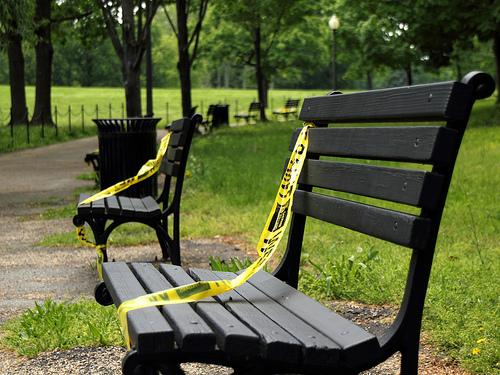How many benches are mentioned in the image? Are there any distinguishing features about these benches? There are a couple of benches with yellow caution tape indicating wet paint, and they seem to be made of wood and are built into the pavement. Identify any possible safety hazards that might be present in this park scene. Potential safety hazards include wet paint on the benches signaled by yellow caution tape. Describe the trash can and its position in the image relative to the benches. A black garbage can is situated in the background, slightly behind and to the side of the benches with caution tape. Based on the information given, provide a simple description of the image. The image shows multiple tall trees, benches with yellow tape, a trash can, and a black fence in a park setting. What standout color is mentioned in the image? What objects have this color? Yellow is the standout color, which is found on caution tape, plastic banner, and dandelions in the scene. Narrate the scene with trees, benches, and caution tape. In a park with tall trees, a couple of wooden benches built into the pavement are wrapped with yellow caution tape, warning of wet paint. Mention any flower species present in the image and their location. Yellow dandelions can be spotted on the ground within the park. Provide a general sentiment analysis of the image. The image has a neutral sentiment, as it depicts an everyday outdoor scene within a park setting. Estimate the total number of objects in the image, including trees, benches, and other items. The image contains at least 31 objects, including trees, benches, and various other items like a trash can, fence, and lightpost. Identify the type of tape on the benches and describe the reason for its presence. Yellow caution tape is placed on the benches, suggesting they are recently painted and still wet. Take a close look at the beautiful red and white flowers growing next to the walking path. Their vibrant colors are striking. There are no red and white flowers mentioned in the image information. This instruction is misleading because it introduces colorful details that are not present in the image. What type of park feature has caution tape wrapped around it? Benches What color are the tape on the benches? Yellow On the bench with the yellow caution tape, you will see a forgotten book. It looks like an interesting read. There is no mention of a forgotten book on any bench in the image information. This instruction is misleading because it introduces a personal item and makes a subjective judgment about its content. What color is the fence in the image? Black Describe the warning message on the tape found on benches. Caution wet paint In addition to the paved path, what other feature is next to the fence? A walking path Provide a brief description of the walking path. A walking path next to the fence and benches Did you notice the flock of birds flying above the park? They appear to be heading south for the winter. There is no reference to a flock of birds or their direction in the image information. This instruction is misleading because it introduces movement and seasonal context that is not present in the image. How many benches are there in the image? A couple of benches Were the benches recently painted? Yes, as indicated by the caution wet paint tape Observe the group of people having a picnic near the tall trees. They seem to be enjoying themselves. There are no people and no picnic mentioned in the image information. This instruction is misleading because it adds a social element that doesn't exist in the image. Do you notice the playful squirrels climbing the tallest tree near the black fence? They are quite agile. No, it's not mentioned in the image. What type of path is near the benches? A paved path Are there any flowers in the image? If so, what are they? Yes, there are yellow dandelions on the ground What are the tall objects located in the park? Tall trees What material are the benches made of? Wood What can be found at the top of the image near the greenery? A light post Which of these items can be found in the image: trash can, swing set, picnic table, or fence? Trash can and fence Identify the specific type of flora on the ground. Yellow dandelions Can you find the large blue ball next to the bench? It is partially covered by a bush. There is no mention of a blue ball or a bush in the given image information. This instruction is misleading because it introduces a nonexistent object and its location. What does the yellow tape on the benches indicate? Wet paint 